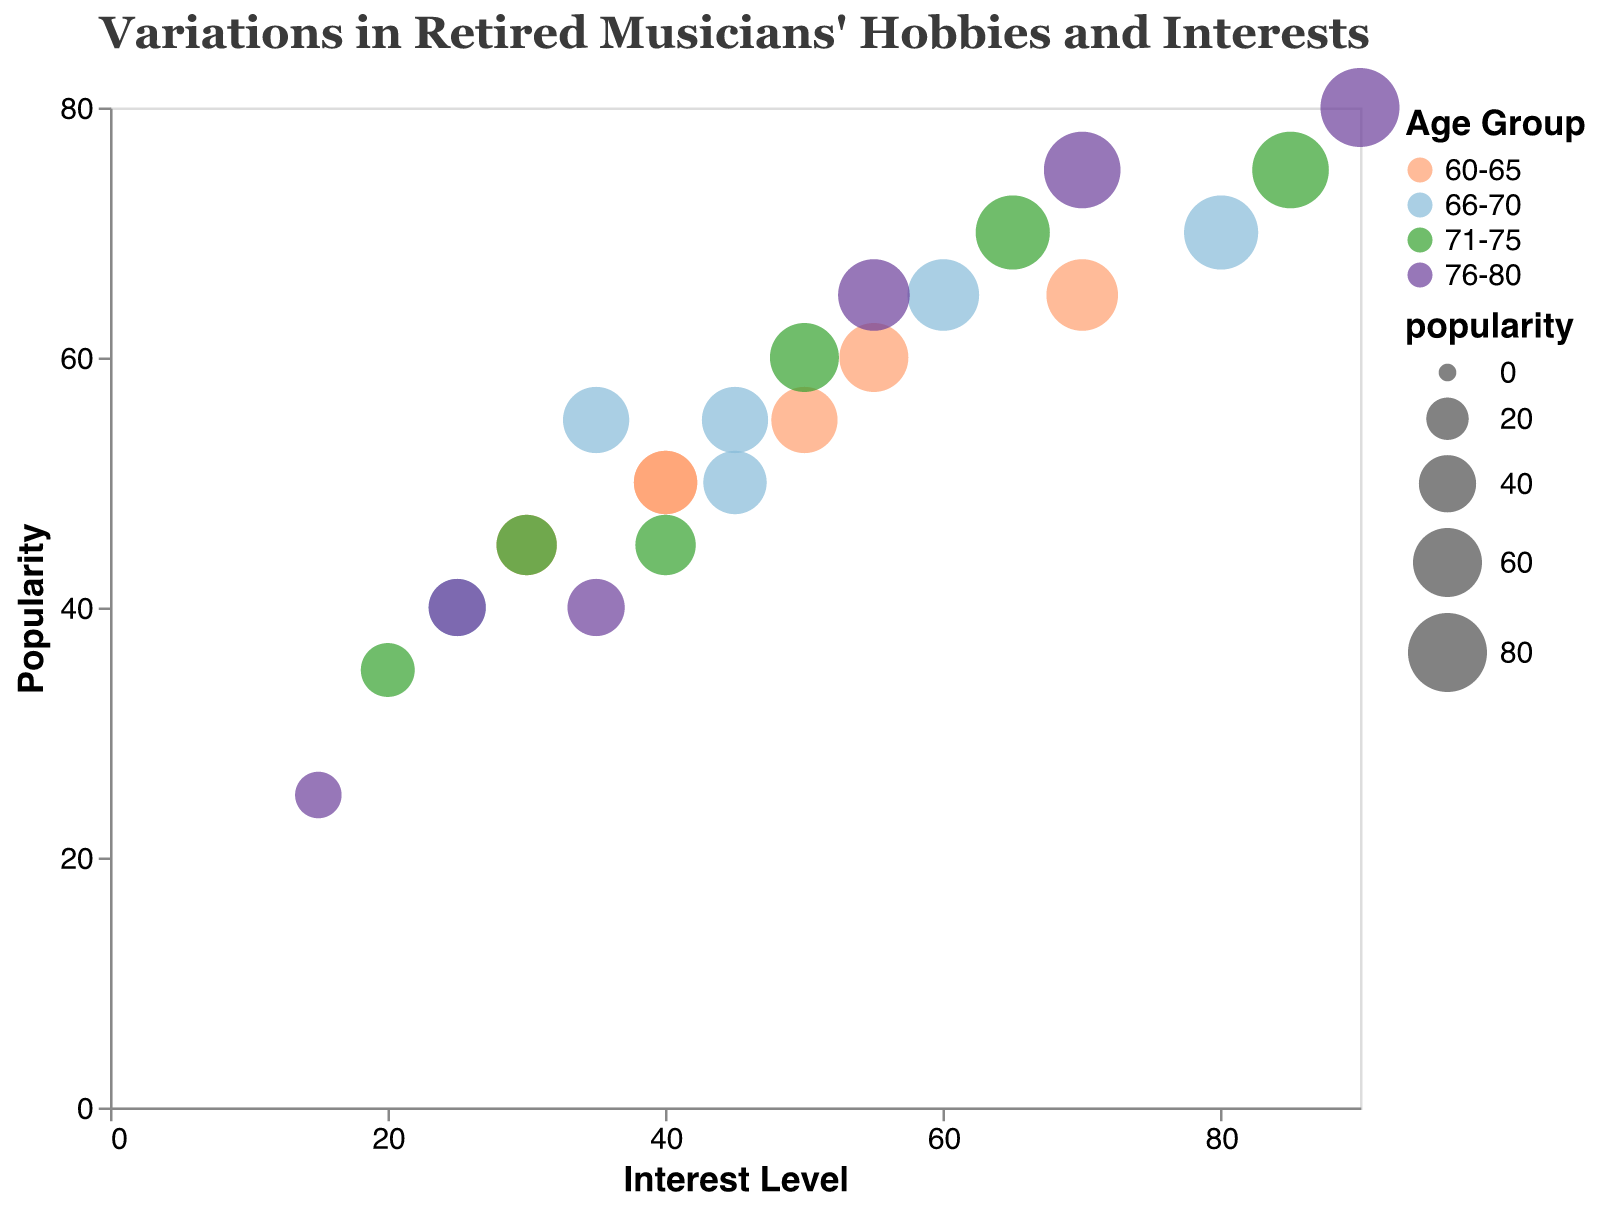What is the title of the figure? The title of the figure is shown at the top and it says "Variations in Retired Musicians' Hobbies and Interests."
Answer: Variations in Retired Musicians' Hobbies and Interests What is the interest level of Cooking for the 71-75 age group? By locating the Cooking hobby within the 71-75 age group, the interest level is indicated on the horizontal axis, which is shown to be 65.
Answer: 65 Which age group has the highest popularity for Reading? The colors in the legend associate age groups with the corresponding data points. The highest popularity value of 80 for Reading is shown with the color representing the 76-80 age group.
Answer: 76-80 How does the interest level for Walking change as age groups increase? By locating the Walking hobby in each age group, the interest level shows a decreasing trend: 40 (60-65), 35 (66-70), 30 (71-75), and 25 (76-80).
Answer: It decreases What hobby has the least popularity in the 76-80 age group? Examining the bubbles for 76-80 age group, the smallest bubble (indicating the least popularity) is for Playing Piano with a popularity of 25.
Answer: Playing Piano Which hobby has the most significant increase in popularity from the 60-65 age group to the 66-70 age group? By comparing popularity values, Cooking increases from 60 (60-65) to 65 (66-70), showing the greatest increase of 5 units.
Answer: Cooking Which age group has the highest interest level for Volunteering? From the color-coded bubbles, the 76-80 age group has the highest interest level of 55 for Volunteering, observed via the horizontal axis.
Answer: 76-80 Compare the interest level and popularity for Reading in the 60-65 and 66-70 age groups. Which has higher in each? For Reading, the interest level in 60-65 is 70, and in 66-70 is 80 (higher). Popularity in 60-65 is 65, and in 66-70 is 70 (higher).
Answer: 66-70 has higher in both What is the average popularity of Cooking across all age groups? Calculate the average by summing the popularity values for Cooking: 60 + 65 + 70 + 75 and then divide by 4 (age groups). (60 + 65 + 70 + 75) / 4 = 67.5
Answer: 67.5 Which hobby shows the greatest decline in interest level from the 66-70 to the 71-75 age group? By comparing the interest levels, Playing Piano declines from 25 (66-70) to 20 (71-75), a decline of 5 units, the greatest among others.
Answer: Playing Piano 